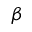<formula> <loc_0><loc_0><loc_500><loc_500>\beta</formula> 